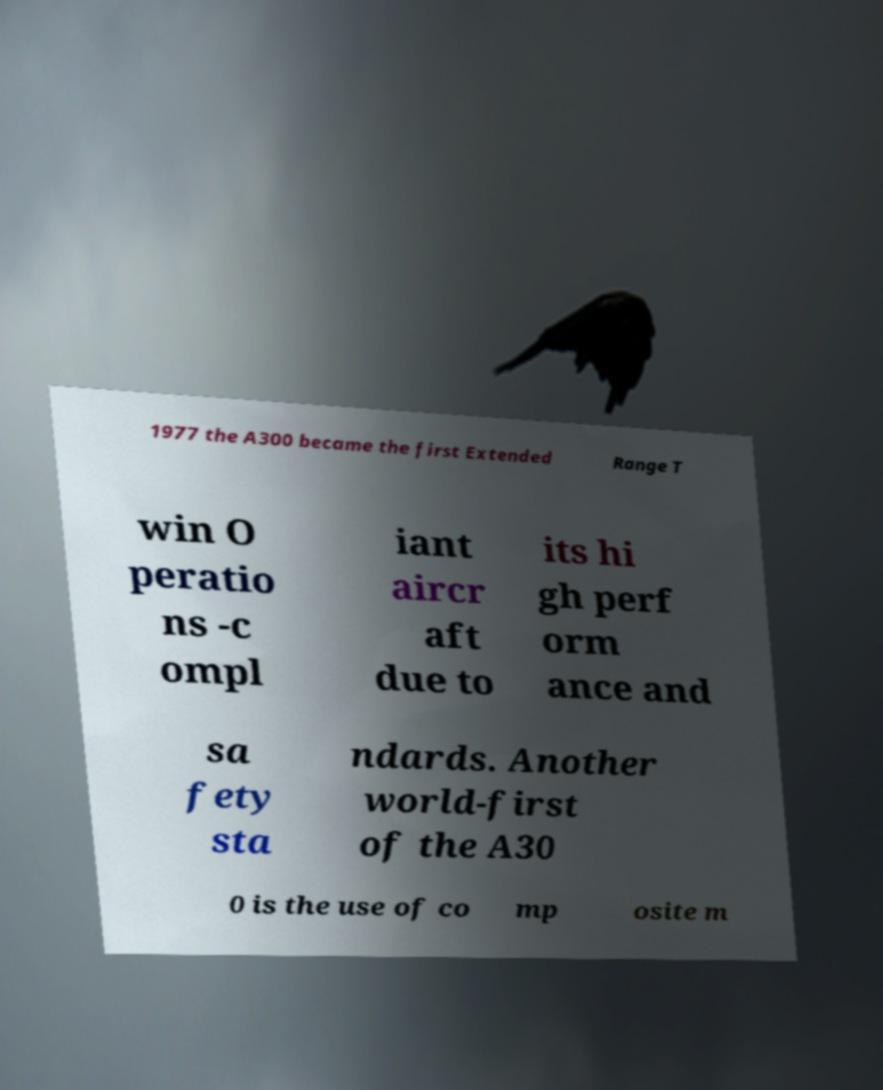Could you assist in decoding the text presented in this image and type it out clearly? 1977 the A300 became the first Extended Range T win O peratio ns -c ompl iant aircr aft due to its hi gh perf orm ance and sa fety sta ndards. Another world-first of the A30 0 is the use of co mp osite m 